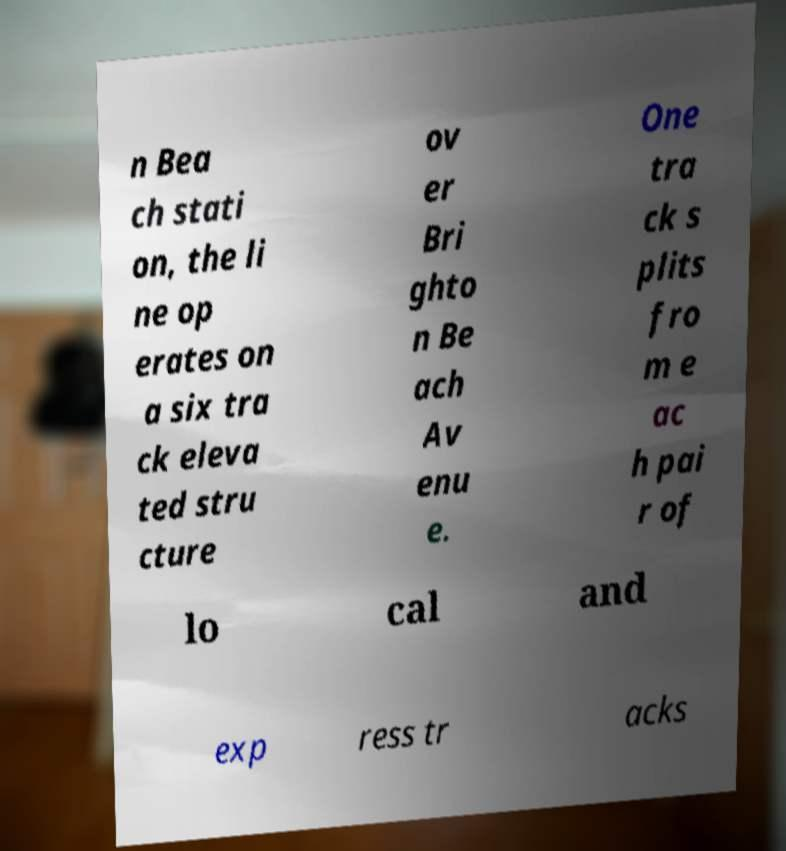For documentation purposes, I need the text within this image transcribed. Could you provide that? n Bea ch stati on, the li ne op erates on a six tra ck eleva ted stru cture ov er Bri ghto n Be ach Av enu e. One tra ck s plits fro m e ac h pai r of lo cal and exp ress tr acks 